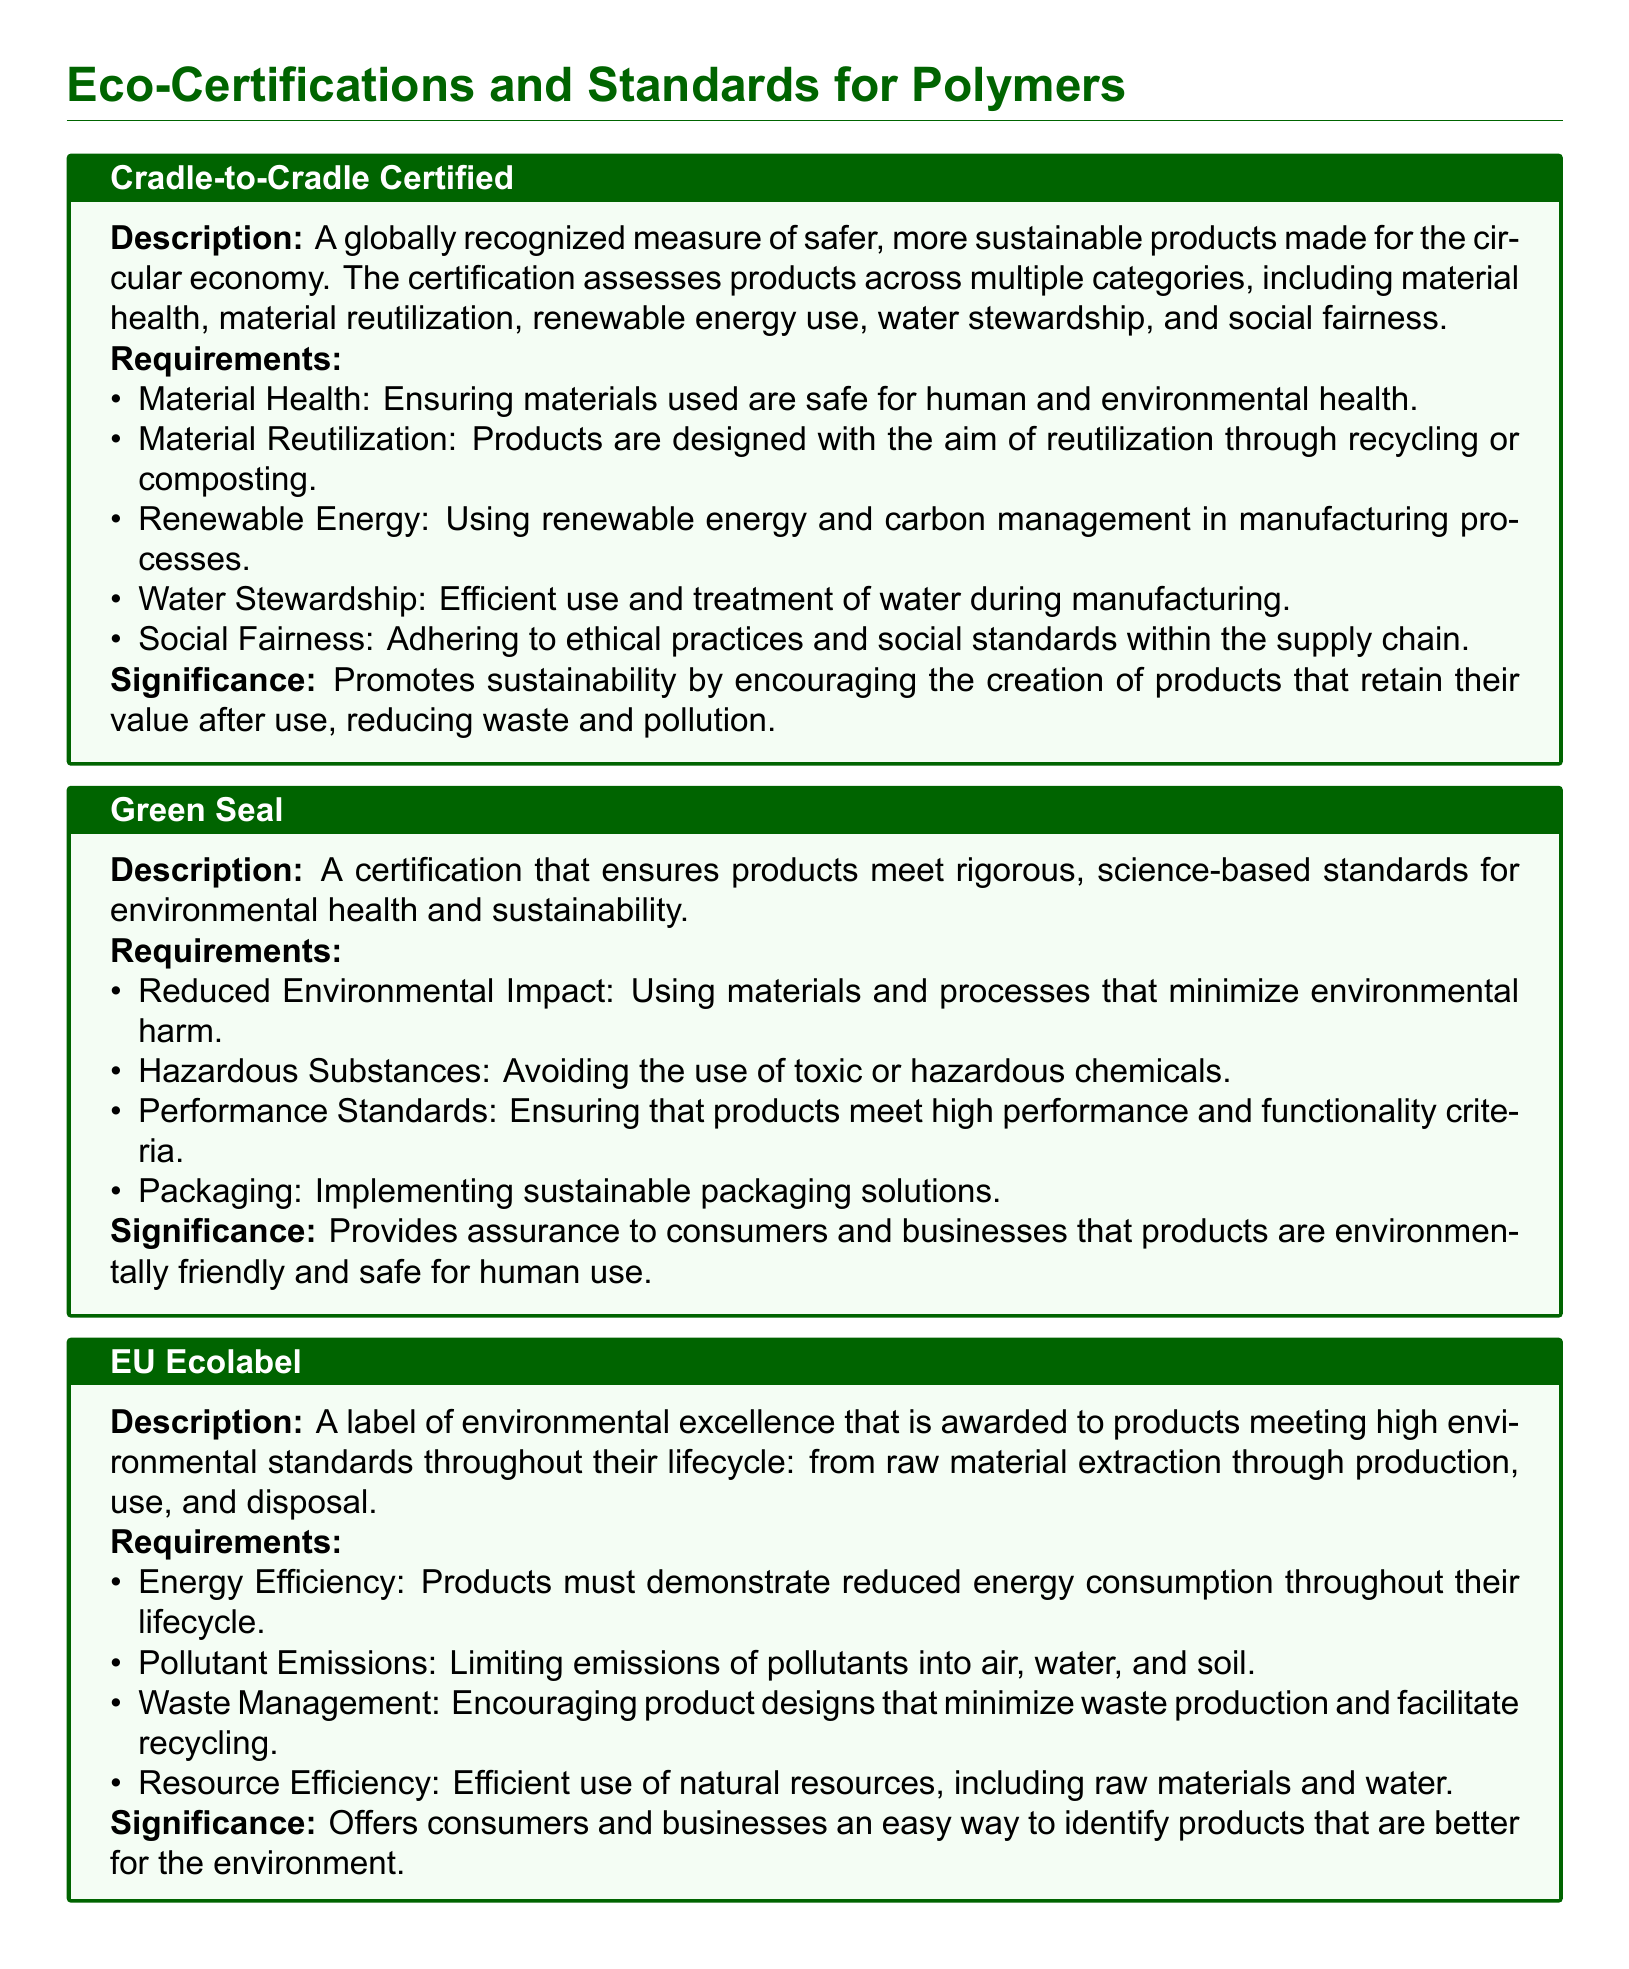What is the certification that measures safer, more sustainable products for the circular economy? This information can be found in the section about Cradle-to-Cradle, which describes its significance in sustainability practices.
Answer: Cradle-to-Cradle Certified What percentage of organic fibers must be used in GOTS certified products? The requirement for organic fiber production in GOTS certification is at least 70%.
Answer: 70% What does the EU Ecolabel address regarding waste management? The document specifies that EU Ecolabel encourages product designs that minimize waste production and facilitate recycling.
Answer: Minimize waste production What is the main focus of REACH regulation? REACH primarily aims to improve the protection of human health and the environment from risks posed by chemicals, as indicated in its description.
Answer: Chemicals What is a requirement for Green Seal certification regarding hazardous substances? The document outlines that Green Seal certification requires avoiding the use of toxic or hazardous chemicals in products.
Answer: Avoiding toxic chemicals What does the term "Material Reutilization" refer to in Cradle-to-Cradle certification? Material Reutilization in Cradle-to-Cradle refers to products being designed for recycling or composting, as described in the listed requirements.
Answer: Recycling or composting What are the pollutant emissions requirements under EU Ecolabel? The EU Ecolabel requires limiting emissions of pollutants into air, water, and soil, according to the requirements listed.
Answer: Limiting emissions What kind of practices does the Cradle-to-Cradle certification promote? The significance section of Cradle-to-Cradle states it promotes sustainability through products that retain their value, reducing waste and pollution.
Answer: Sustainability What is the significant impact of Green Seal certification for consumers? The significance of Green Seal certification ensures that products are environmentally friendly and safe for human use, which is key for consumer assurance.
Answer: Assurance 